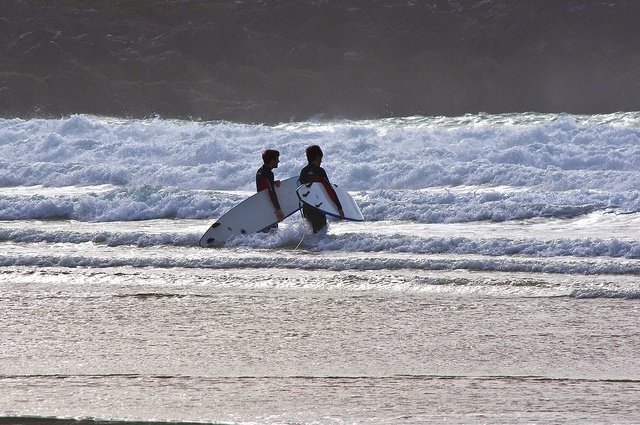Describe the objects in this image and their specific colors. I can see surfboard in black, gray, and navy tones, people in black and gray tones, surfboard in black, gray, and darkgray tones, and people in black and gray tones in this image. 